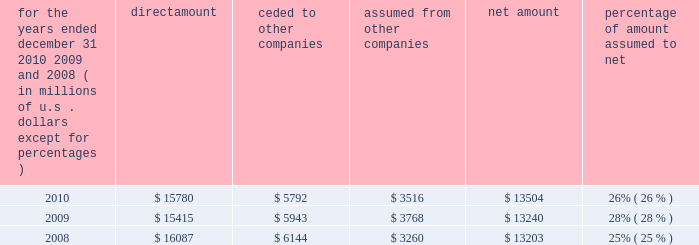S c h e d u l e i v ace limited and subsidiaries s u p p l e m e n t a l i n f o r m a t i o n c o n c e r n i n g r e i n s u r a n c e premiums earned for the years ended december 31 , 2010 , 2009 , and 2008 ( in millions of u.s .
Dollars , except for percentages ) direct amount ceded to companies assumed from other companies net amount percentage of amount assumed to .

What is the difference between the ceded and assumed amounts in 2010? 
Computations: (5792 - 3516)
Answer: 2276.0. 